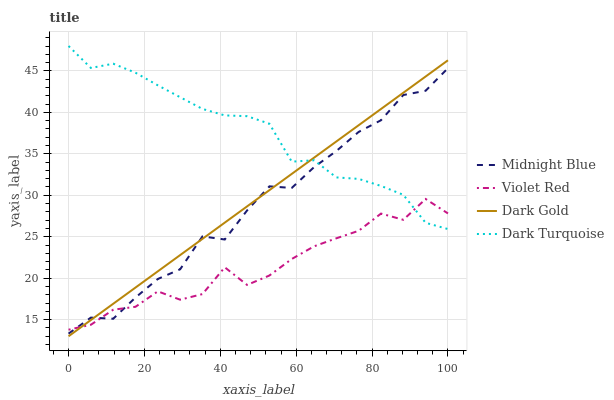Does Violet Red have the minimum area under the curve?
Answer yes or no. Yes. Does Dark Turquoise have the maximum area under the curve?
Answer yes or no. Yes. Does Midnight Blue have the minimum area under the curve?
Answer yes or no. No. Does Midnight Blue have the maximum area under the curve?
Answer yes or no. No. Is Dark Gold the smoothest?
Answer yes or no. Yes. Is Violet Red the roughest?
Answer yes or no. Yes. Is Midnight Blue the smoothest?
Answer yes or no. No. Is Midnight Blue the roughest?
Answer yes or no. No. Does Dark Gold have the lowest value?
Answer yes or no. Yes. Does Violet Red have the lowest value?
Answer yes or no. No. Does Dark Turquoise have the highest value?
Answer yes or no. Yes. Does Midnight Blue have the highest value?
Answer yes or no. No. Does Dark Gold intersect Dark Turquoise?
Answer yes or no. Yes. Is Dark Gold less than Dark Turquoise?
Answer yes or no. No. Is Dark Gold greater than Dark Turquoise?
Answer yes or no. No. 